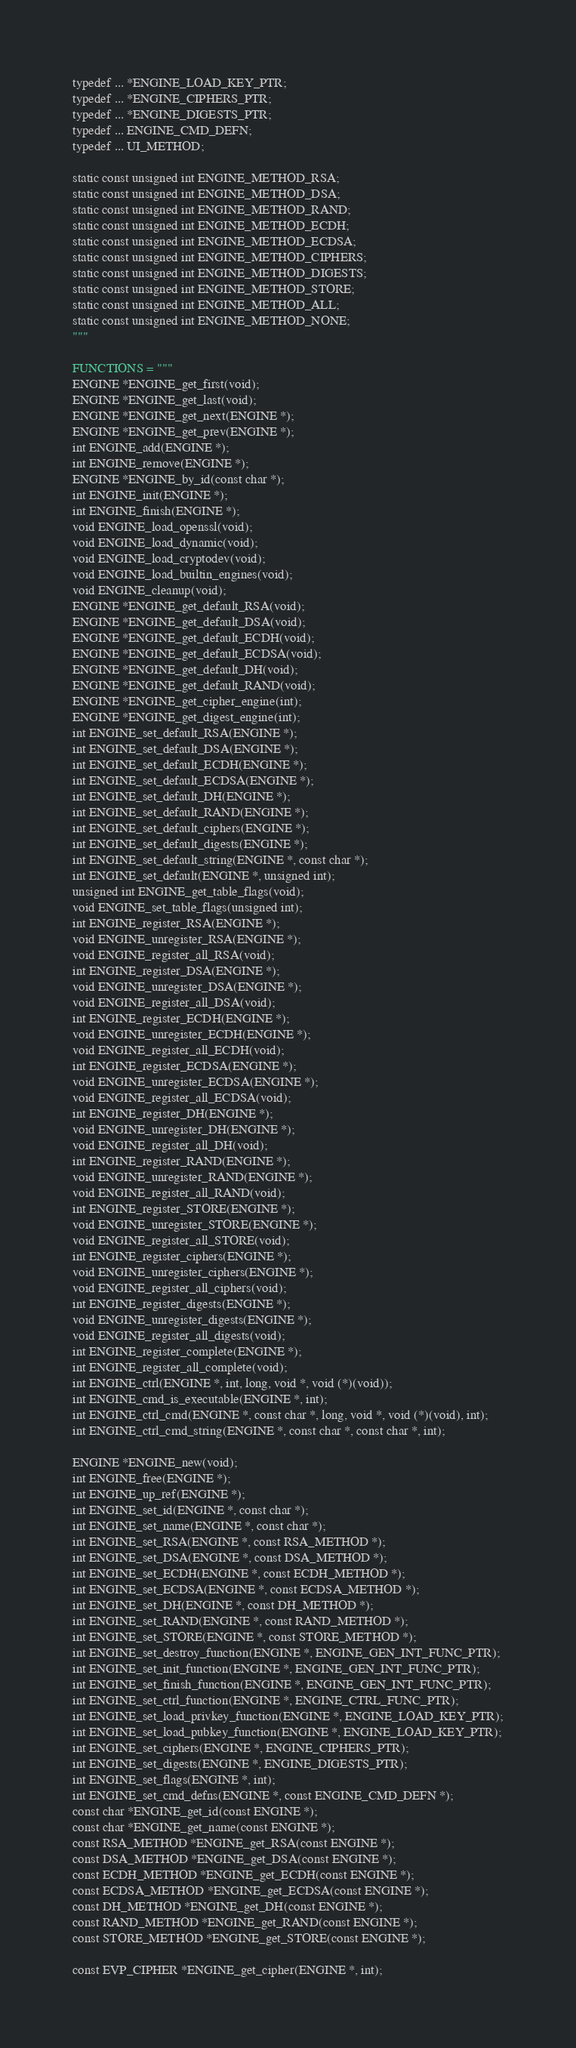<code> <loc_0><loc_0><loc_500><loc_500><_Python_>typedef ... *ENGINE_LOAD_KEY_PTR;
typedef ... *ENGINE_CIPHERS_PTR;
typedef ... *ENGINE_DIGESTS_PTR;
typedef ... ENGINE_CMD_DEFN;
typedef ... UI_METHOD;

static const unsigned int ENGINE_METHOD_RSA;
static const unsigned int ENGINE_METHOD_DSA;
static const unsigned int ENGINE_METHOD_RAND;
static const unsigned int ENGINE_METHOD_ECDH;
static const unsigned int ENGINE_METHOD_ECDSA;
static const unsigned int ENGINE_METHOD_CIPHERS;
static const unsigned int ENGINE_METHOD_DIGESTS;
static const unsigned int ENGINE_METHOD_STORE;
static const unsigned int ENGINE_METHOD_ALL;
static const unsigned int ENGINE_METHOD_NONE;
"""

FUNCTIONS = """
ENGINE *ENGINE_get_first(void);
ENGINE *ENGINE_get_last(void);
ENGINE *ENGINE_get_next(ENGINE *);
ENGINE *ENGINE_get_prev(ENGINE *);
int ENGINE_add(ENGINE *);
int ENGINE_remove(ENGINE *);
ENGINE *ENGINE_by_id(const char *);
int ENGINE_init(ENGINE *);
int ENGINE_finish(ENGINE *);
void ENGINE_load_openssl(void);
void ENGINE_load_dynamic(void);
void ENGINE_load_cryptodev(void);
void ENGINE_load_builtin_engines(void);
void ENGINE_cleanup(void);
ENGINE *ENGINE_get_default_RSA(void);
ENGINE *ENGINE_get_default_DSA(void);
ENGINE *ENGINE_get_default_ECDH(void);
ENGINE *ENGINE_get_default_ECDSA(void);
ENGINE *ENGINE_get_default_DH(void);
ENGINE *ENGINE_get_default_RAND(void);
ENGINE *ENGINE_get_cipher_engine(int);
ENGINE *ENGINE_get_digest_engine(int);
int ENGINE_set_default_RSA(ENGINE *);
int ENGINE_set_default_DSA(ENGINE *);
int ENGINE_set_default_ECDH(ENGINE *);
int ENGINE_set_default_ECDSA(ENGINE *);
int ENGINE_set_default_DH(ENGINE *);
int ENGINE_set_default_RAND(ENGINE *);
int ENGINE_set_default_ciphers(ENGINE *);
int ENGINE_set_default_digests(ENGINE *);
int ENGINE_set_default_string(ENGINE *, const char *);
int ENGINE_set_default(ENGINE *, unsigned int);
unsigned int ENGINE_get_table_flags(void);
void ENGINE_set_table_flags(unsigned int);
int ENGINE_register_RSA(ENGINE *);
void ENGINE_unregister_RSA(ENGINE *);
void ENGINE_register_all_RSA(void);
int ENGINE_register_DSA(ENGINE *);
void ENGINE_unregister_DSA(ENGINE *);
void ENGINE_register_all_DSA(void);
int ENGINE_register_ECDH(ENGINE *);
void ENGINE_unregister_ECDH(ENGINE *);
void ENGINE_register_all_ECDH(void);
int ENGINE_register_ECDSA(ENGINE *);
void ENGINE_unregister_ECDSA(ENGINE *);
void ENGINE_register_all_ECDSA(void);
int ENGINE_register_DH(ENGINE *);
void ENGINE_unregister_DH(ENGINE *);
void ENGINE_register_all_DH(void);
int ENGINE_register_RAND(ENGINE *);
void ENGINE_unregister_RAND(ENGINE *);
void ENGINE_register_all_RAND(void);
int ENGINE_register_STORE(ENGINE *);
void ENGINE_unregister_STORE(ENGINE *);
void ENGINE_register_all_STORE(void);
int ENGINE_register_ciphers(ENGINE *);
void ENGINE_unregister_ciphers(ENGINE *);
void ENGINE_register_all_ciphers(void);
int ENGINE_register_digests(ENGINE *);
void ENGINE_unregister_digests(ENGINE *);
void ENGINE_register_all_digests(void);
int ENGINE_register_complete(ENGINE *);
int ENGINE_register_all_complete(void);
int ENGINE_ctrl(ENGINE *, int, long, void *, void (*)(void));
int ENGINE_cmd_is_executable(ENGINE *, int);
int ENGINE_ctrl_cmd(ENGINE *, const char *, long, void *, void (*)(void), int);
int ENGINE_ctrl_cmd_string(ENGINE *, const char *, const char *, int);

ENGINE *ENGINE_new(void);
int ENGINE_free(ENGINE *);
int ENGINE_up_ref(ENGINE *);
int ENGINE_set_id(ENGINE *, const char *);
int ENGINE_set_name(ENGINE *, const char *);
int ENGINE_set_RSA(ENGINE *, const RSA_METHOD *);
int ENGINE_set_DSA(ENGINE *, const DSA_METHOD *);
int ENGINE_set_ECDH(ENGINE *, const ECDH_METHOD *);
int ENGINE_set_ECDSA(ENGINE *, const ECDSA_METHOD *);
int ENGINE_set_DH(ENGINE *, const DH_METHOD *);
int ENGINE_set_RAND(ENGINE *, const RAND_METHOD *);
int ENGINE_set_STORE(ENGINE *, const STORE_METHOD *);
int ENGINE_set_destroy_function(ENGINE *, ENGINE_GEN_INT_FUNC_PTR);
int ENGINE_set_init_function(ENGINE *, ENGINE_GEN_INT_FUNC_PTR);
int ENGINE_set_finish_function(ENGINE *, ENGINE_GEN_INT_FUNC_PTR);
int ENGINE_set_ctrl_function(ENGINE *, ENGINE_CTRL_FUNC_PTR);
int ENGINE_set_load_privkey_function(ENGINE *, ENGINE_LOAD_KEY_PTR);
int ENGINE_set_load_pubkey_function(ENGINE *, ENGINE_LOAD_KEY_PTR);
int ENGINE_set_ciphers(ENGINE *, ENGINE_CIPHERS_PTR);
int ENGINE_set_digests(ENGINE *, ENGINE_DIGESTS_PTR);
int ENGINE_set_flags(ENGINE *, int);
int ENGINE_set_cmd_defns(ENGINE *, const ENGINE_CMD_DEFN *);
const char *ENGINE_get_id(const ENGINE *);
const char *ENGINE_get_name(const ENGINE *);
const RSA_METHOD *ENGINE_get_RSA(const ENGINE *);
const DSA_METHOD *ENGINE_get_DSA(const ENGINE *);
const ECDH_METHOD *ENGINE_get_ECDH(const ENGINE *);
const ECDSA_METHOD *ENGINE_get_ECDSA(const ENGINE *);
const DH_METHOD *ENGINE_get_DH(const ENGINE *);
const RAND_METHOD *ENGINE_get_RAND(const ENGINE *);
const STORE_METHOD *ENGINE_get_STORE(const ENGINE *);

const EVP_CIPHER *ENGINE_get_cipher(ENGINE *, int);</code> 